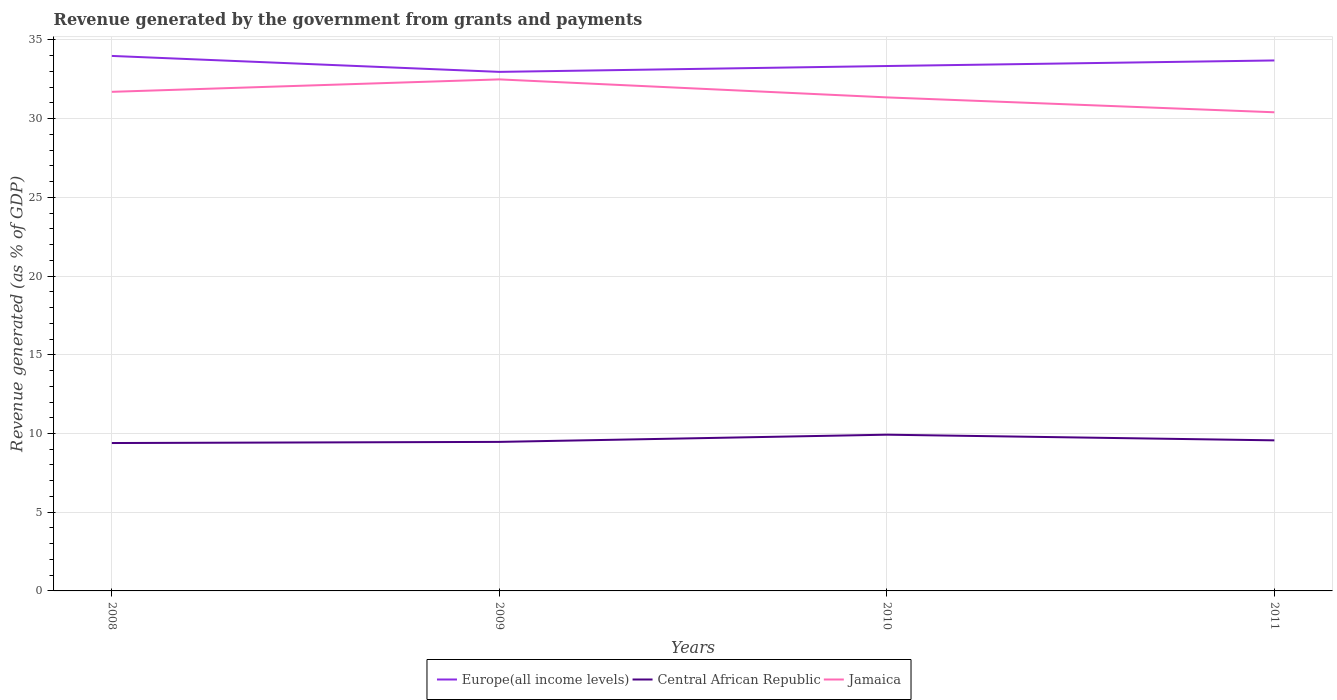How many different coloured lines are there?
Your answer should be very brief. 3. Does the line corresponding to Jamaica intersect with the line corresponding to Central African Republic?
Offer a very short reply. No. Is the number of lines equal to the number of legend labels?
Provide a short and direct response. Yes. Across all years, what is the maximum revenue generated by the government in Jamaica?
Give a very brief answer. 30.4. In which year was the revenue generated by the government in Europe(all income levels) maximum?
Provide a short and direct response. 2009. What is the total revenue generated by the government in Europe(all income levels) in the graph?
Give a very brief answer. -0.73. What is the difference between the highest and the second highest revenue generated by the government in Jamaica?
Keep it short and to the point. 2.09. What is the difference between the highest and the lowest revenue generated by the government in Central African Republic?
Keep it short and to the point. 1. Where does the legend appear in the graph?
Offer a terse response. Bottom center. How many legend labels are there?
Offer a very short reply. 3. How are the legend labels stacked?
Your answer should be compact. Horizontal. What is the title of the graph?
Provide a succinct answer. Revenue generated by the government from grants and payments. Does "India" appear as one of the legend labels in the graph?
Make the answer very short. No. What is the label or title of the X-axis?
Offer a terse response. Years. What is the label or title of the Y-axis?
Provide a short and direct response. Revenue generated (as % of GDP). What is the Revenue generated (as % of GDP) of Europe(all income levels) in 2008?
Make the answer very short. 33.98. What is the Revenue generated (as % of GDP) in Central African Republic in 2008?
Your answer should be compact. 9.39. What is the Revenue generated (as % of GDP) in Jamaica in 2008?
Offer a terse response. 31.7. What is the Revenue generated (as % of GDP) of Europe(all income levels) in 2009?
Provide a short and direct response. 32.97. What is the Revenue generated (as % of GDP) in Central African Republic in 2009?
Provide a short and direct response. 9.47. What is the Revenue generated (as % of GDP) of Jamaica in 2009?
Provide a succinct answer. 32.49. What is the Revenue generated (as % of GDP) in Europe(all income levels) in 2010?
Offer a terse response. 33.34. What is the Revenue generated (as % of GDP) of Central African Republic in 2010?
Give a very brief answer. 9.92. What is the Revenue generated (as % of GDP) of Jamaica in 2010?
Keep it short and to the point. 31.35. What is the Revenue generated (as % of GDP) in Europe(all income levels) in 2011?
Give a very brief answer. 33.7. What is the Revenue generated (as % of GDP) of Central African Republic in 2011?
Provide a short and direct response. 9.56. What is the Revenue generated (as % of GDP) of Jamaica in 2011?
Give a very brief answer. 30.4. Across all years, what is the maximum Revenue generated (as % of GDP) of Europe(all income levels)?
Ensure brevity in your answer.  33.98. Across all years, what is the maximum Revenue generated (as % of GDP) in Central African Republic?
Offer a very short reply. 9.92. Across all years, what is the maximum Revenue generated (as % of GDP) of Jamaica?
Keep it short and to the point. 32.49. Across all years, what is the minimum Revenue generated (as % of GDP) of Europe(all income levels)?
Your response must be concise. 32.97. Across all years, what is the minimum Revenue generated (as % of GDP) of Central African Republic?
Provide a succinct answer. 9.39. Across all years, what is the minimum Revenue generated (as % of GDP) of Jamaica?
Make the answer very short. 30.4. What is the total Revenue generated (as % of GDP) in Europe(all income levels) in the graph?
Provide a succinct answer. 133.99. What is the total Revenue generated (as % of GDP) in Central African Republic in the graph?
Provide a short and direct response. 38.35. What is the total Revenue generated (as % of GDP) of Jamaica in the graph?
Provide a succinct answer. 125.95. What is the difference between the Revenue generated (as % of GDP) in Europe(all income levels) in 2008 and that in 2009?
Your response must be concise. 1.01. What is the difference between the Revenue generated (as % of GDP) in Central African Republic in 2008 and that in 2009?
Your response must be concise. -0.07. What is the difference between the Revenue generated (as % of GDP) of Jamaica in 2008 and that in 2009?
Your response must be concise. -0.79. What is the difference between the Revenue generated (as % of GDP) of Europe(all income levels) in 2008 and that in 2010?
Give a very brief answer. 0.64. What is the difference between the Revenue generated (as % of GDP) of Central African Republic in 2008 and that in 2010?
Keep it short and to the point. -0.53. What is the difference between the Revenue generated (as % of GDP) of Jamaica in 2008 and that in 2010?
Your answer should be compact. 0.35. What is the difference between the Revenue generated (as % of GDP) in Europe(all income levels) in 2008 and that in 2011?
Give a very brief answer. 0.29. What is the difference between the Revenue generated (as % of GDP) of Central African Republic in 2008 and that in 2011?
Offer a terse response. -0.17. What is the difference between the Revenue generated (as % of GDP) of Jamaica in 2008 and that in 2011?
Ensure brevity in your answer.  1.3. What is the difference between the Revenue generated (as % of GDP) in Europe(all income levels) in 2009 and that in 2010?
Your response must be concise. -0.37. What is the difference between the Revenue generated (as % of GDP) in Central African Republic in 2009 and that in 2010?
Offer a terse response. -0.46. What is the difference between the Revenue generated (as % of GDP) of Jamaica in 2009 and that in 2010?
Your response must be concise. 1.14. What is the difference between the Revenue generated (as % of GDP) in Europe(all income levels) in 2009 and that in 2011?
Provide a succinct answer. -0.73. What is the difference between the Revenue generated (as % of GDP) of Central African Republic in 2009 and that in 2011?
Make the answer very short. -0.1. What is the difference between the Revenue generated (as % of GDP) of Jamaica in 2009 and that in 2011?
Offer a very short reply. 2.09. What is the difference between the Revenue generated (as % of GDP) in Europe(all income levels) in 2010 and that in 2011?
Ensure brevity in your answer.  -0.35. What is the difference between the Revenue generated (as % of GDP) in Central African Republic in 2010 and that in 2011?
Offer a terse response. 0.36. What is the difference between the Revenue generated (as % of GDP) in Jamaica in 2010 and that in 2011?
Provide a short and direct response. 0.95. What is the difference between the Revenue generated (as % of GDP) in Europe(all income levels) in 2008 and the Revenue generated (as % of GDP) in Central African Republic in 2009?
Ensure brevity in your answer.  24.52. What is the difference between the Revenue generated (as % of GDP) of Europe(all income levels) in 2008 and the Revenue generated (as % of GDP) of Jamaica in 2009?
Your response must be concise. 1.49. What is the difference between the Revenue generated (as % of GDP) of Central African Republic in 2008 and the Revenue generated (as % of GDP) of Jamaica in 2009?
Offer a terse response. -23.1. What is the difference between the Revenue generated (as % of GDP) in Europe(all income levels) in 2008 and the Revenue generated (as % of GDP) in Central African Republic in 2010?
Make the answer very short. 24.06. What is the difference between the Revenue generated (as % of GDP) in Europe(all income levels) in 2008 and the Revenue generated (as % of GDP) in Jamaica in 2010?
Ensure brevity in your answer.  2.63. What is the difference between the Revenue generated (as % of GDP) of Central African Republic in 2008 and the Revenue generated (as % of GDP) of Jamaica in 2010?
Give a very brief answer. -21.95. What is the difference between the Revenue generated (as % of GDP) of Europe(all income levels) in 2008 and the Revenue generated (as % of GDP) of Central African Republic in 2011?
Offer a terse response. 24.42. What is the difference between the Revenue generated (as % of GDP) of Europe(all income levels) in 2008 and the Revenue generated (as % of GDP) of Jamaica in 2011?
Your answer should be compact. 3.58. What is the difference between the Revenue generated (as % of GDP) of Central African Republic in 2008 and the Revenue generated (as % of GDP) of Jamaica in 2011?
Ensure brevity in your answer.  -21.01. What is the difference between the Revenue generated (as % of GDP) in Europe(all income levels) in 2009 and the Revenue generated (as % of GDP) in Central African Republic in 2010?
Your response must be concise. 23.05. What is the difference between the Revenue generated (as % of GDP) in Europe(all income levels) in 2009 and the Revenue generated (as % of GDP) in Jamaica in 2010?
Offer a terse response. 1.62. What is the difference between the Revenue generated (as % of GDP) in Central African Republic in 2009 and the Revenue generated (as % of GDP) in Jamaica in 2010?
Offer a very short reply. -21.88. What is the difference between the Revenue generated (as % of GDP) of Europe(all income levels) in 2009 and the Revenue generated (as % of GDP) of Central African Republic in 2011?
Your response must be concise. 23.41. What is the difference between the Revenue generated (as % of GDP) in Europe(all income levels) in 2009 and the Revenue generated (as % of GDP) in Jamaica in 2011?
Make the answer very short. 2.57. What is the difference between the Revenue generated (as % of GDP) of Central African Republic in 2009 and the Revenue generated (as % of GDP) of Jamaica in 2011?
Your answer should be very brief. -20.94. What is the difference between the Revenue generated (as % of GDP) in Europe(all income levels) in 2010 and the Revenue generated (as % of GDP) in Central African Republic in 2011?
Your answer should be very brief. 23.78. What is the difference between the Revenue generated (as % of GDP) of Europe(all income levels) in 2010 and the Revenue generated (as % of GDP) of Jamaica in 2011?
Keep it short and to the point. 2.94. What is the difference between the Revenue generated (as % of GDP) in Central African Republic in 2010 and the Revenue generated (as % of GDP) in Jamaica in 2011?
Provide a succinct answer. -20.48. What is the average Revenue generated (as % of GDP) in Europe(all income levels) per year?
Give a very brief answer. 33.5. What is the average Revenue generated (as % of GDP) of Central African Republic per year?
Your answer should be compact. 9.59. What is the average Revenue generated (as % of GDP) of Jamaica per year?
Your answer should be very brief. 31.49. In the year 2008, what is the difference between the Revenue generated (as % of GDP) of Europe(all income levels) and Revenue generated (as % of GDP) of Central African Republic?
Make the answer very short. 24.59. In the year 2008, what is the difference between the Revenue generated (as % of GDP) of Europe(all income levels) and Revenue generated (as % of GDP) of Jamaica?
Make the answer very short. 2.28. In the year 2008, what is the difference between the Revenue generated (as % of GDP) of Central African Republic and Revenue generated (as % of GDP) of Jamaica?
Offer a very short reply. -22.31. In the year 2009, what is the difference between the Revenue generated (as % of GDP) in Europe(all income levels) and Revenue generated (as % of GDP) in Central African Republic?
Your answer should be compact. 23.5. In the year 2009, what is the difference between the Revenue generated (as % of GDP) in Europe(all income levels) and Revenue generated (as % of GDP) in Jamaica?
Provide a succinct answer. 0.48. In the year 2009, what is the difference between the Revenue generated (as % of GDP) in Central African Republic and Revenue generated (as % of GDP) in Jamaica?
Offer a very short reply. -23.03. In the year 2010, what is the difference between the Revenue generated (as % of GDP) of Europe(all income levels) and Revenue generated (as % of GDP) of Central African Republic?
Your answer should be very brief. 23.42. In the year 2010, what is the difference between the Revenue generated (as % of GDP) in Europe(all income levels) and Revenue generated (as % of GDP) in Jamaica?
Make the answer very short. 1.99. In the year 2010, what is the difference between the Revenue generated (as % of GDP) of Central African Republic and Revenue generated (as % of GDP) of Jamaica?
Make the answer very short. -21.43. In the year 2011, what is the difference between the Revenue generated (as % of GDP) of Europe(all income levels) and Revenue generated (as % of GDP) of Central African Republic?
Give a very brief answer. 24.13. In the year 2011, what is the difference between the Revenue generated (as % of GDP) in Europe(all income levels) and Revenue generated (as % of GDP) in Jamaica?
Ensure brevity in your answer.  3.29. In the year 2011, what is the difference between the Revenue generated (as % of GDP) of Central African Republic and Revenue generated (as % of GDP) of Jamaica?
Your answer should be compact. -20.84. What is the ratio of the Revenue generated (as % of GDP) in Europe(all income levels) in 2008 to that in 2009?
Your answer should be very brief. 1.03. What is the ratio of the Revenue generated (as % of GDP) in Jamaica in 2008 to that in 2009?
Make the answer very short. 0.98. What is the ratio of the Revenue generated (as % of GDP) in Europe(all income levels) in 2008 to that in 2010?
Keep it short and to the point. 1.02. What is the ratio of the Revenue generated (as % of GDP) of Central African Republic in 2008 to that in 2010?
Give a very brief answer. 0.95. What is the ratio of the Revenue generated (as % of GDP) of Jamaica in 2008 to that in 2010?
Keep it short and to the point. 1.01. What is the ratio of the Revenue generated (as % of GDP) in Europe(all income levels) in 2008 to that in 2011?
Your response must be concise. 1.01. What is the ratio of the Revenue generated (as % of GDP) of Central African Republic in 2008 to that in 2011?
Your answer should be compact. 0.98. What is the ratio of the Revenue generated (as % of GDP) in Jamaica in 2008 to that in 2011?
Your answer should be compact. 1.04. What is the ratio of the Revenue generated (as % of GDP) in Europe(all income levels) in 2009 to that in 2010?
Keep it short and to the point. 0.99. What is the ratio of the Revenue generated (as % of GDP) of Central African Republic in 2009 to that in 2010?
Offer a very short reply. 0.95. What is the ratio of the Revenue generated (as % of GDP) in Jamaica in 2009 to that in 2010?
Ensure brevity in your answer.  1.04. What is the ratio of the Revenue generated (as % of GDP) in Europe(all income levels) in 2009 to that in 2011?
Make the answer very short. 0.98. What is the ratio of the Revenue generated (as % of GDP) in Central African Republic in 2009 to that in 2011?
Offer a terse response. 0.99. What is the ratio of the Revenue generated (as % of GDP) in Jamaica in 2009 to that in 2011?
Your answer should be very brief. 1.07. What is the ratio of the Revenue generated (as % of GDP) in Central African Republic in 2010 to that in 2011?
Provide a short and direct response. 1.04. What is the ratio of the Revenue generated (as % of GDP) in Jamaica in 2010 to that in 2011?
Make the answer very short. 1.03. What is the difference between the highest and the second highest Revenue generated (as % of GDP) in Europe(all income levels)?
Provide a succinct answer. 0.29. What is the difference between the highest and the second highest Revenue generated (as % of GDP) in Central African Republic?
Provide a succinct answer. 0.36. What is the difference between the highest and the second highest Revenue generated (as % of GDP) in Jamaica?
Your answer should be very brief. 0.79. What is the difference between the highest and the lowest Revenue generated (as % of GDP) in Europe(all income levels)?
Ensure brevity in your answer.  1.01. What is the difference between the highest and the lowest Revenue generated (as % of GDP) in Central African Republic?
Your answer should be compact. 0.53. What is the difference between the highest and the lowest Revenue generated (as % of GDP) of Jamaica?
Make the answer very short. 2.09. 